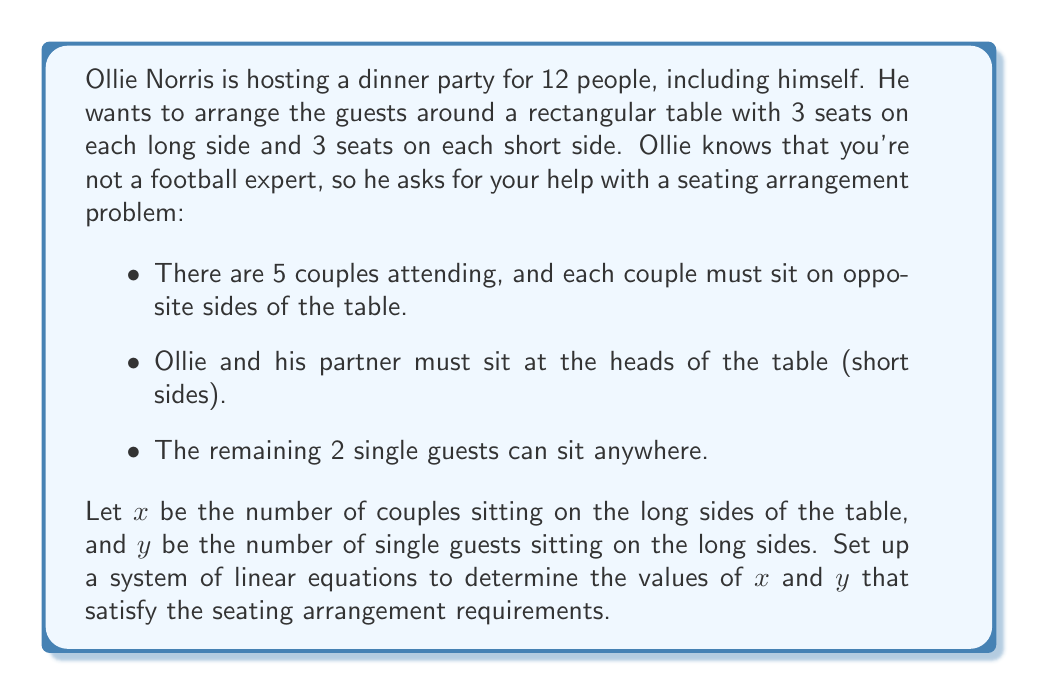Could you help me with this problem? Let's approach this problem step by step:

1. First, let's define our variables:
   $x$ = number of couples sitting on the long sides of the table
   $y$ = number of single guests sitting on the long sides of the table

2. Now, let's consider the constraints:
   - There are 6 seats total on the long sides of the table (3 on each side)
   - Each couple occupies 2 seats (one on each side)
   - Single guests occupy 1 seat each
   - Ollie and his partner occupy the 2 seats on the short sides

3. We can now form our first equation:
   Total seats on long sides = Seats occupied by couples + Seats occupied by singles
   $$6 = 2x + y$$

4. For our second equation, we need to consider the total number of people:
   - There are 5 couples in total (10 people)
   - There are 2 single guests
   - Ollie and his partner are already accounted for on the short sides

   So, we need to place 4 couples and 2 singles on the long sides:
   $$4 = x + y$$

5. Now we have a system of two linear equations:
   $$\begin{cases}
   6 = 2x + y \\
   4 = x + y
   \end{cases}$$

6. To solve this system, we can use substitution. From the second equation:
   $$y = 4 - x$$

7. Substituting this into the first equation:
   $$6 = 2x + (4 - x)$$
   $$6 = 2x + 4 - x$$
   $$6 = x + 4$$
   $$2 = x$$

8. Now we can find $y$ by substituting $x = 2$ into either of our original equations:
   $$4 = 2 + y$$
   $$y = 2$$

Therefore, the solution is $x = 2$ and $y = 2$.
Answer: The solution to the system of equations is $x = 2$ and $y = 2$. This means that 2 couples and 2 single guests should be seated on the long sides of the table to satisfy the seating arrangement requirements. 